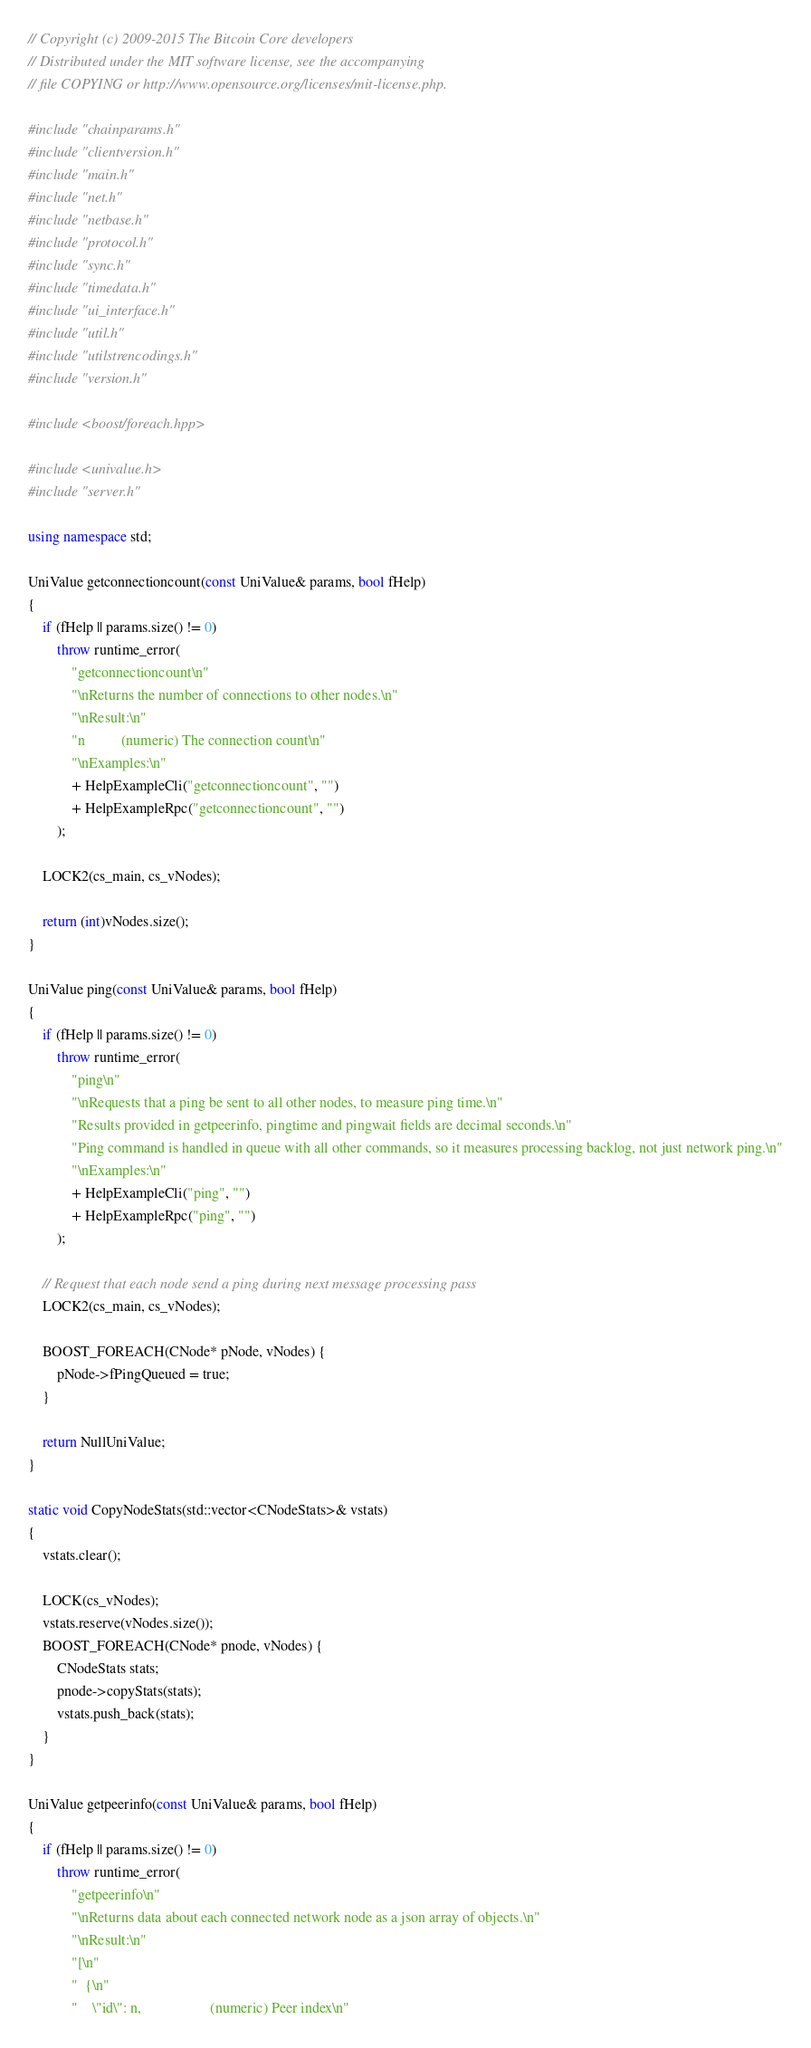<code> <loc_0><loc_0><loc_500><loc_500><_C++_>// Copyright (c) 2009-2015 The Bitcoin Core developers
// Distributed under the MIT software license, see the accompanying
// file COPYING or http://www.opensource.org/licenses/mit-license.php.

#include "chainparams.h"
#include "clientversion.h"
#include "main.h"
#include "net.h"
#include "netbase.h"
#include "protocol.h"
#include "sync.h"
#include "timedata.h"
#include "ui_interface.h"
#include "util.h"
#include "utilstrencodings.h"
#include "version.h"

#include <boost/foreach.hpp>

#include <univalue.h>
#include "server.h"

using namespace std;

UniValue getconnectioncount(const UniValue& params, bool fHelp)
{
    if (fHelp || params.size() != 0)
        throw runtime_error(
            "getconnectioncount\n"
            "\nReturns the number of connections to other nodes.\n"
            "\nResult:\n"
            "n          (numeric) The connection count\n"
            "\nExamples:\n"
            + HelpExampleCli("getconnectioncount", "")
            + HelpExampleRpc("getconnectioncount", "")
        );

    LOCK2(cs_main, cs_vNodes);

    return (int)vNodes.size();
}

UniValue ping(const UniValue& params, bool fHelp)
{
    if (fHelp || params.size() != 0)
        throw runtime_error(
            "ping\n"
            "\nRequests that a ping be sent to all other nodes, to measure ping time.\n"
            "Results provided in getpeerinfo, pingtime and pingwait fields are decimal seconds.\n"
            "Ping command is handled in queue with all other commands, so it measures processing backlog, not just network ping.\n"
            "\nExamples:\n"
            + HelpExampleCli("ping", "")
            + HelpExampleRpc("ping", "")
        );

    // Request that each node send a ping during next message processing pass
    LOCK2(cs_main, cs_vNodes);

    BOOST_FOREACH(CNode* pNode, vNodes) {
        pNode->fPingQueued = true;
    }

    return NullUniValue;
}

static void CopyNodeStats(std::vector<CNodeStats>& vstats)
{
    vstats.clear();

    LOCK(cs_vNodes);
    vstats.reserve(vNodes.size());
    BOOST_FOREACH(CNode* pnode, vNodes) {
        CNodeStats stats;
        pnode->copyStats(stats);
        vstats.push_back(stats);
    }
}

UniValue getpeerinfo(const UniValue& params, bool fHelp)
{
    if (fHelp || params.size() != 0)
        throw runtime_error(
            "getpeerinfo\n"
            "\nReturns data about each connected network node as a json array of objects.\n"
            "\nResult:\n"
            "[\n"
            "  {\n"
            "    \"id\": n,                   (numeric) Peer index\n"</code> 